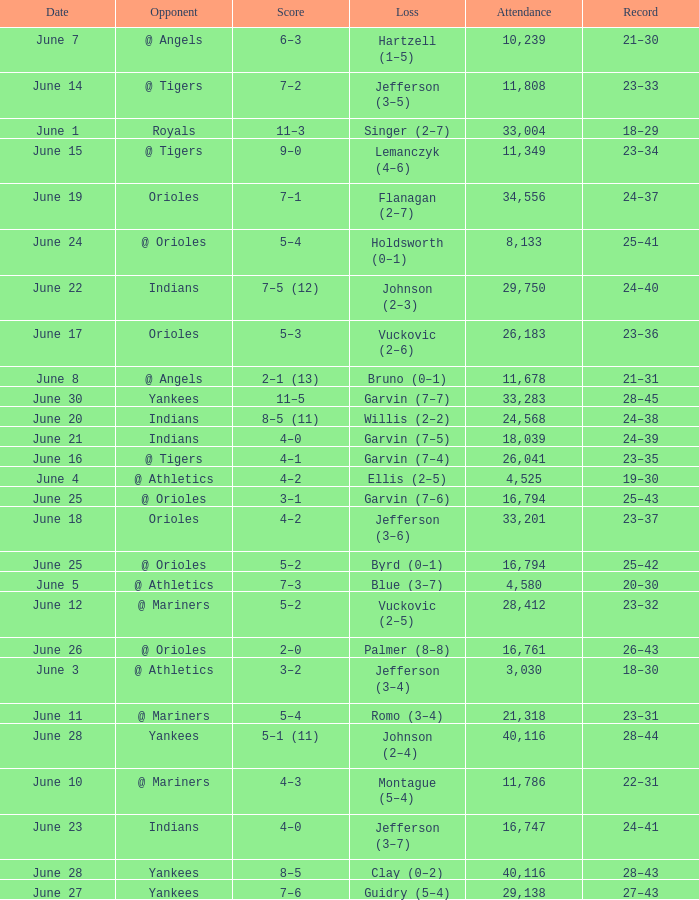Who was the opponent at the game when the record was 28–45? Yankees. 